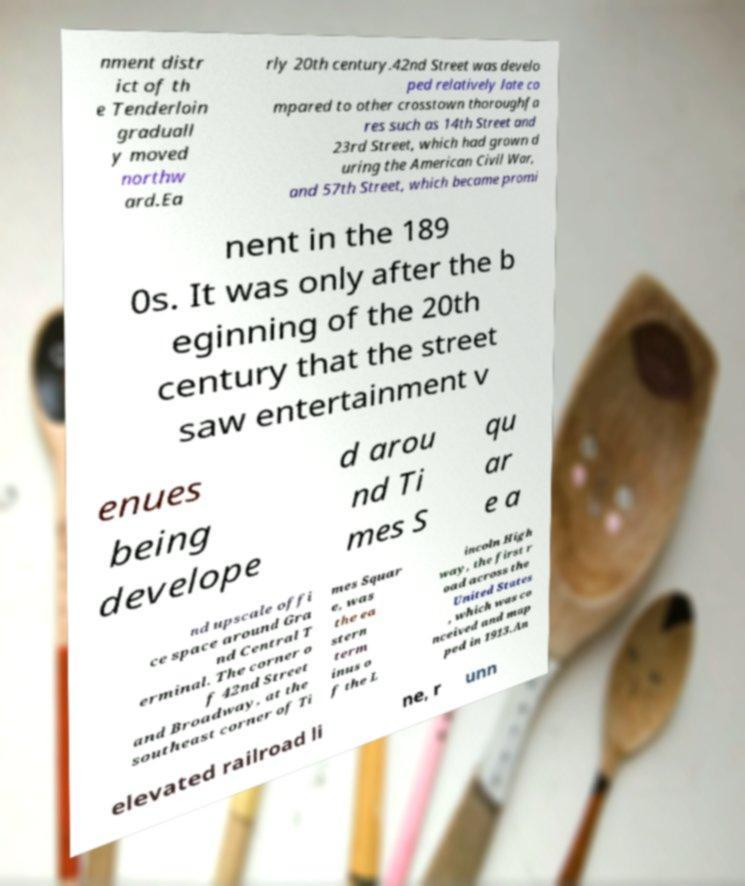Can you read and provide the text displayed in the image?This photo seems to have some interesting text. Can you extract and type it out for me? nment distr ict of th e Tenderloin graduall y moved northw ard.Ea rly 20th century.42nd Street was develo ped relatively late co mpared to other crosstown thoroughfa res such as 14th Street and 23rd Street, which had grown d uring the American Civil War, and 57th Street, which became promi nent in the 189 0s. It was only after the b eginning of the 20th century that the street saw entertainment v enues being develope d arou nd Ti mes S qu ar e a nd upscale offi ce space around Gra nd Central T erminal. The corner o f 42nd Street and Broadway, at the southeast corner of Ti mes Squar e, was the ea stern term inus o f the L incoln High way, the first r oad across the United States , which was co nceived and map ped in 1913.An elevated railroad li ne, r unn 